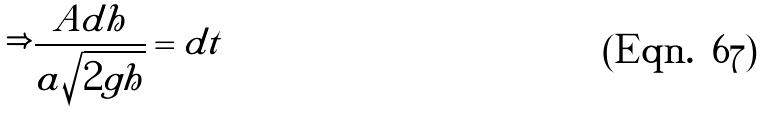Convert formula to latex. <formula><loc_0><loc_0><loc_500><loc_500>\Rightarrow \frac { A d h } { a \sqrt { 2 g h } } = d t</formula> 